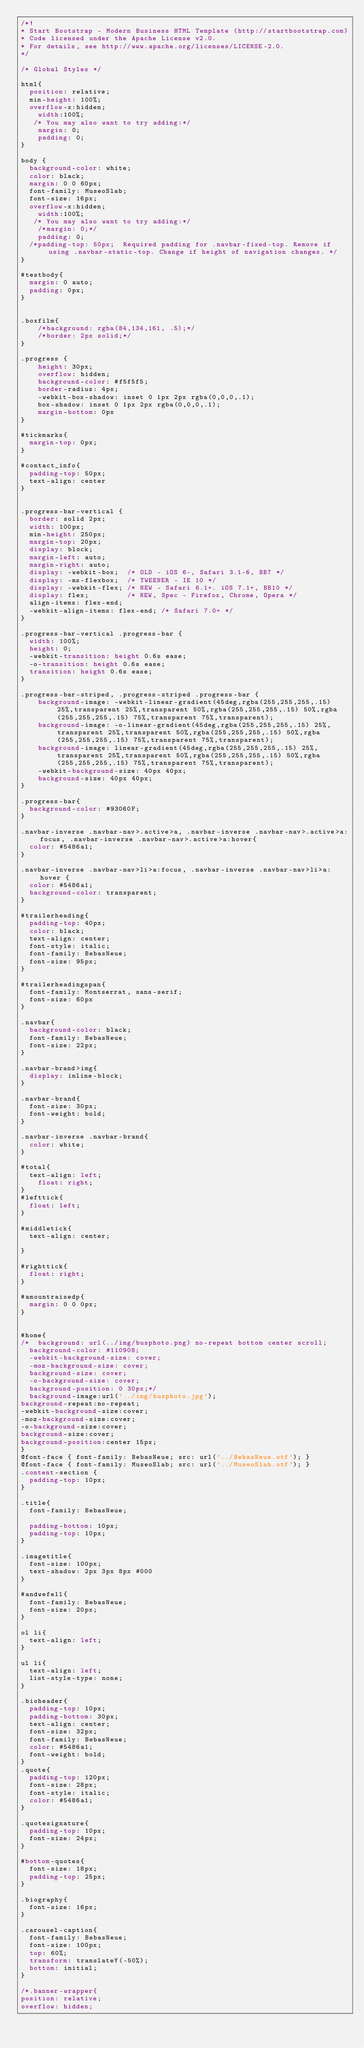<code> <loc_0><loc_0><loc_500><loc_500><_CSS_>/*!
* Start Bootstrap - Modern Business HTML Template (http://startbootstrap.com)
* Code licensed under the Apache License v2.0.
* For details, see http://www.apache.org/licenses/LICENSE-2.0.
*/

/* Global Styles */

html{
	position: relative;
	min-height: 100%;
	overflow-x:hidden;
    width:100%;
   /* You may also want to try adding:*/
    margin: 0;
    padding: 0;
}

body {  
	background-color: white;
	color: black;
	margin: 0 0 60px;
	font-family: MuseoSlab;
	font-size: 16px;
	overflow-x:hidden;
    width:100%;
   /* You may also want to try adding:*/
    /*margin: 0;*/
    padding: 0;
	/*padding-top: 50px;  Required padding for .navbar-fixed-top. Remove if using .navbar-static-top. Change if height of navigation changes. */
}

#testbody{
	margin: 0 auto; 
	padding: 0px; 
}


.boxfilm{
    /*background: rgba(84,134,161, .5);*/
    /*border: 2px solid;*/
}

.progress {
    height: 30px;
    overflow: hidden;
    background-color: #f5f5f5;
    border-radius: 4px;
    -webkit-box-shadow: inset 0 1px 2px rgba(0,0,0,.1);
    box-shadow: inset 0 1px 2px rgba(0,0,0,.1);
    margin-bottom: 0px
}

#tickmarks{
	margin-top: 0px;
}

#contact_info{
	padding-top: 50px;
	text-align: center
}


.progress-bar-vertical {
	border: solid 2px;
	width: 100px;
	min-height: 250px;
	margin-top: 20px;
	display: block;
	margin-left: auto;
	margin-right: auto;
	display: -webkit-box;  /* OLD - iOS 6-, Safari 3.1-6, BB7 */
	display: -ms-flexbox;  /* TWEENER - IE 10 */
	display: -webkit-flex; /* NEW - Safari 6.1+. iOS 7.1+, BB10 */
	display: flex;         /* NEW, Spec - Firefox, Chrome, Opera */
	align-items: flex-end;
	-webkit-align-items: flex-end; /* Safari 7.0+ */
}

.progress-bar-vertical .progress-bar {
	width: 100%;
	height: 0;
	-webkit-transition: height 0.6s ease;
	-o-transition: height 0.6s ease;
	transition: height 0.6s ease;
}

.progress-bar-striped, .progress-striped .progress-bar {
    background-image: -webkit-linear-gradient(45deg,rgba(255,255,255,.15) 25%,transparent 25%,transparent 50%,rgba(255,255,255,.15) 50%,rgba(255,255,255,.15) 75%,transparent 75%,transparent);
    background-image: -o-linear-gradient(45deg,rgba(255,255,255,.15) 25%,transparent 25%,transparent 50%,rgba(255,255,255,.15) 50%,rgba(255,255,255,.15) 75%,transparent 75%,transparent);
    background-image: linear-gradient(45deg,rgba(255,255,255,.15) 25%,transparent 25%,transparent 50%,rgba(255,255,255,.15) 50%,rgba(255,255,255,.15) 75%,transparent 75%,transparent);
    -webkit-background-size: 40px 40px;
    background-size: 40px 40px;
}

.progress-bar{
	background-color: #93060F;
}

.navbar-inverse .navbar-nav>.active>a, .navbar-inverse .navbar-nav>.active>a:focus, .navbar-inverse .navbar-nav>.active>a:hover{
	color: #5486a1;
}

.navbar-inverse .navbar-nav>li>a:focus, .navbar-inverse .navbar-nav>li>a:hover {
	color: #5486a1;
	background-color: transparent;
}

#trailerheading{
	padding-top: 40px;
	color: black;
	text-align: center;
	font-style: italic;
	font-family: BebasNeue;
	font-size: 95px;
}

#trailerheadingspan{
	font-family: Montserrat, sans-serif; 
	font-size: 60px
}

.navbar{
	background-color: black;
	font-family: BebasNeue;
	font-size: 22px;
}

.navbar-brand>img{
	display: inline-block;
}

.navbar-brand{
	font-size: 30px;
	font-weight: bold;
}

.navbar-inverse .navbar-brand{
	color: white;
}

#total{
	text-align: left;
    float: right;
}
#lefttick{
	float: left;
}

#middletick{
	text-align: center;
    
}

#righttick{
	float: right;
}

#amountraisedp{
	margin: 0 0 0px;
}


#home{
/*	background: url(../img/busphoto.png) no-repeat bottom center scroll;
	background-color: #110908;
	-webkit-background-size: cover;
	-moz-background-size: cover;
	background-size: cover;
	-o-background-size: cover;
	background-position: 0 30px;*/
	background-image:url('../img/busphoto.jpg');
background-repeat:no-repeat;
-webkit-background-size:cover;
-moz-background-size:cover;
-o-background-size:cover;
background-size:cover;
background-position:center 15px;
}
@font-face { font-family: BebasNeue; src: url('../BebasNeue.otf'); }
@font-face { font-family: MuseoSlab; src: url('../MuseoSlab.otf'); }
.content-section {
	padding-top: 10px;
}

.title{
	font-family: BebasNeue;

	padding-bottom: 10px;
	padding-top: 10px;
}

.imagetitle{
	font-size: 100px;
	text-shadow: 2px 3px 8px #000
}

#andwefell{
	font-family: BebasNeue;
	font-size: 20px;
}

ol li{
	text-align: left;
}

ul li{
	text-align: left;
	list-style-type: none;
}

.bioheader{
	padding-top: 10px;
	padding-bottom: 30px;
	text-align: center;
	font-size: 32px;
	font-family: BebasNeue;
	color: #5486a1;
	font-weight: bold;
}
.quote{
	padding-top: 120px;
	font-size: 28px;
	font-style: italic;
	color: #5486a1;
}

.quotesignature{
	padding-top: 10px;
	font-size: 24px;
}

#bottom-quotes{
	font-size: 18px;
	padding-top: 25px;
}

.biography{
	font-size: 16px;
}

.carousel-caption{
	font-family: BebasNeue;
	font-size: 100px;
	top: 60%;
	transform: translateY(-50%);
	bottom: initial;
}

/*.banner-wrapper{
position: relative;
overflow: hidden;</code> 